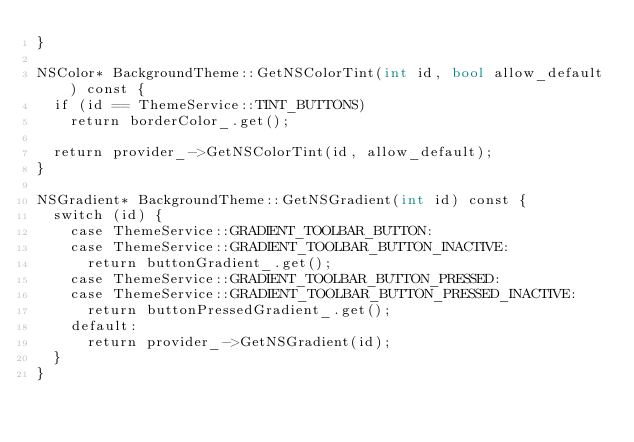<code> <loc_0><loc_0><loc_500><loc_500><_ObjectiveC_>}

NSColor* BackgroundTheme::GetNSColorTint(int id, bool allow_default) const {
  if (id == ThemeService::TINT_BUTTONS)
    return borderColor_.get();

  return provider_->GetNSColorTint(id, allow_default);
}

NSGradient* BackgroundTheme::GetNSGradient(int id) const {
  switch (id) {
    case ThemeService::GRADIENT_TOOLBAR_BUTTON:
    case ThemeService::GRADIENT_TOOLBAR_BUTTON_INACTIVE:
      return buttonGradient_.get();
    case ThemeService::GRADIENT_TOOLBAR_BUTTON_PRESSED:
    case ThemeService::GRADIENT_TOOLBAR_BUTTON_PRESSED_INACTIVE:
      return buttonPressedGradient_.get();
    default:
      return provider_->GetNSGradient(id);
  }
}


</code> 